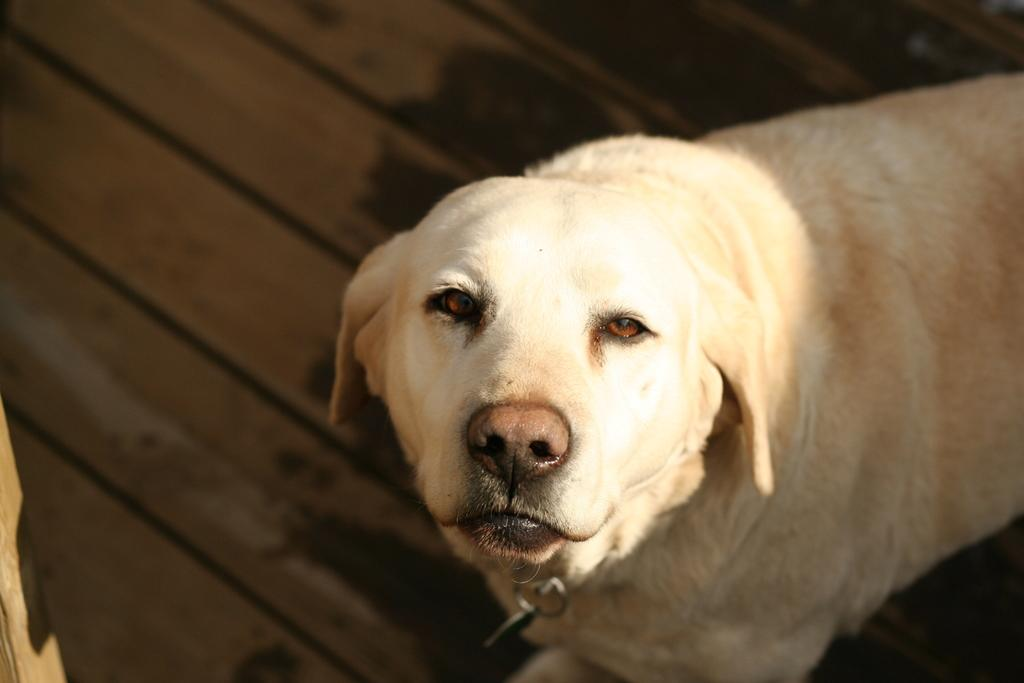What type of animal is in the image? There is a white dog in the image. What is the surface beneath the dog? The dog is on the wooden floor. What type of leather is the jellyfish wearing in the image? There is no jellyfish or leather present in the image; it features a white dog on a wooden floor. 